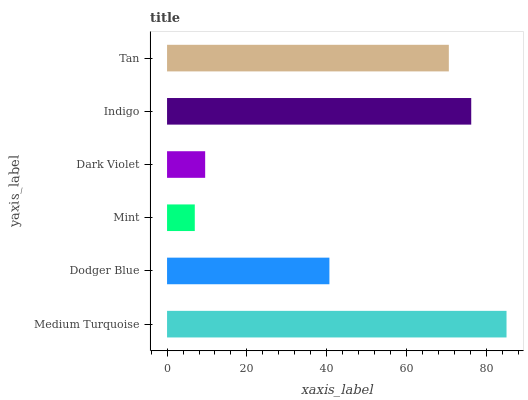Is Mint the minimum?
Answer yes or no. Yes. Is Medium Turquoise the maximum?
Answer yes or no. Yes. Is Dodger Blue the minimum?
Answer yes or no. No. Is Dodger Blue the maximum?
Answer yes or no. No. Is Medium Turquoise greater than Dodger Blue?
Answer yes or no. Yes. Is Dodger Blue less than Medium Turquoise?
Answer yes or no. Yes. Is Dodger Blue greater than Medium Turquoise?
Answer yes or no. No. Is Medium Turquoise less than Dodger Blue?
Answer yes or no. No. Is Tan the high median?
Answer yes or no. Yes. Is Dodger Blue the low median?
Answer yes or no. Yes. Is Dark Violet the high median?
Answer yes or no. No. Is Tan the low median?
Answer yes or no. No. 